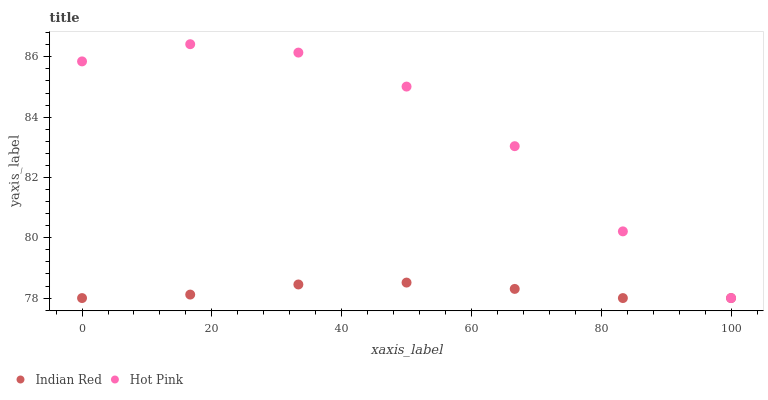Does Indian Red have the minimum area under the curve?
Answer yes or no. Yes. Does Hot Pink have the maximum area under the curve?
Answer yes or no. Yes. Does Indian Red have the maximum area under the curve?
Answer yes or no. No. Is Indian Red the smoothest?
Answer yes or no. Yes. Is Hot Pink the roughest?
Answer yes or no. Yes. Is Indian Red the roughest?
Answer yes or no. No. Does Hot Pink have the lowest value?
Answer yes or no. Yes. Does Hot Pink have the highest value?
Answer yes or no. Yes. Does Indian Red have the highest value?
Answer yes or no. No. Does Hot Pink intersect Indian Red?
Answer yes or no. Yes. Is Hot Pink less than Indian Red?
Answer yes or no. No. Is Hot Pink greater than Indian Red?
Answer yes or no. No. 